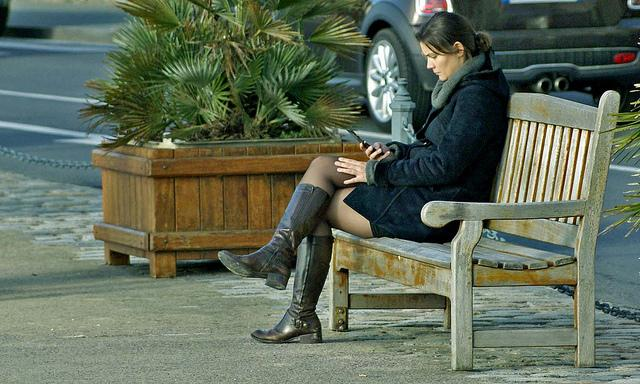What is she doing? Please explain your reasoning. texting friend. Most people use phones for texting or talking. 